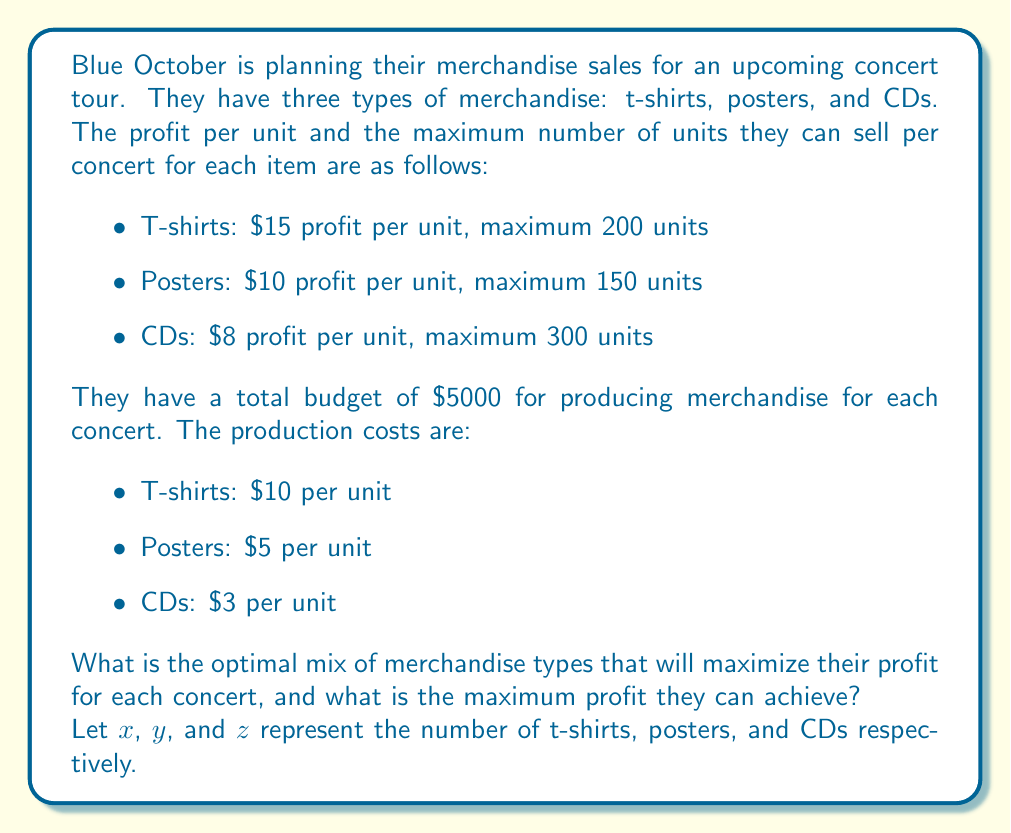Show me your answer to this math problem. To solve this optimization problem, we need to set up a linear programming model:

Objective function (maximize profit):
$$ \text{Maximize } P = 15x + 10y + 8z $$

Subject to the following constraints:

1. Production budget constraint:
$$ 10x + 5y + 3z \leq 5000 $$

2. Maximum sales constraints:
$$ x \leq 200 $$
$$ y \leq 150 $$
$$ z \leq 300 $$

3. Non-negativity constraints:
$$ x, y, z \geq 0 $$

We can solve this using the simplex method or a graphical method. However, given the constraints, we can also use a logical approach:

1. T-shirts have the highest profit per unit, so we should maximize these first. We can produce and sell 200 t-shirts:
   $200 \times $10 = $2000 production cost
   Remaining budget: $5000 - $2000 = $3000

2. Posters have the next highest profit per unit. We can produce and sell 150 posters:
   $150 \times $5 = $750 production cost
   Remaining budget: $3000 - $750 = $2250

3. With the remaining budget, we can produce CDs:
   $2250 ÷ $3 = 750 CDs, but we're limited to selling 300.
   So we produce 300 CDs: $300 \times $3 = $900 production cost

Therefore, the optimal mix is:
- 200 t-shirts
- 150 posters
- 300 CDs

The maximum profit can be calculated as:
$$ P = (15 \times 200) + (10 \times 150) + (8 \times 300) = 3000 + 1500 + 2400 = 6900 $$
Answer: The optimal mix of merchandise is 200 t-shirts, 150 posters, and 300 CDs. The maximum profit that can be achieved is $6900 per concert. 